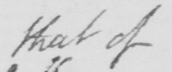Please provide the text content of this handwritten line. that of 